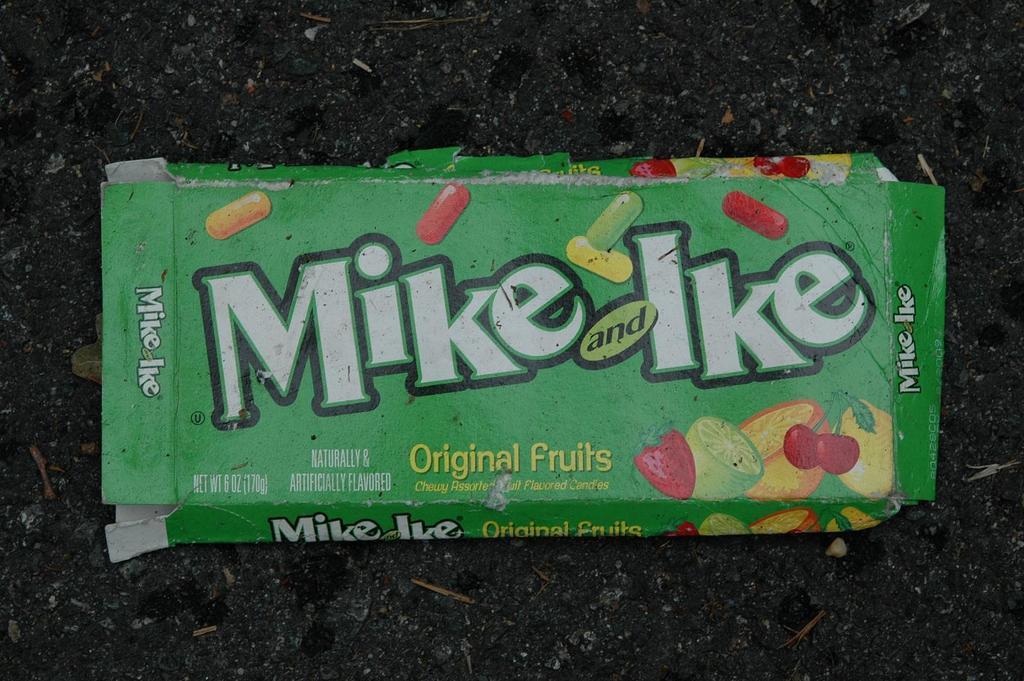How would you summarize this image in a sentence or two? In this image we can see the empty candy wrapper. 